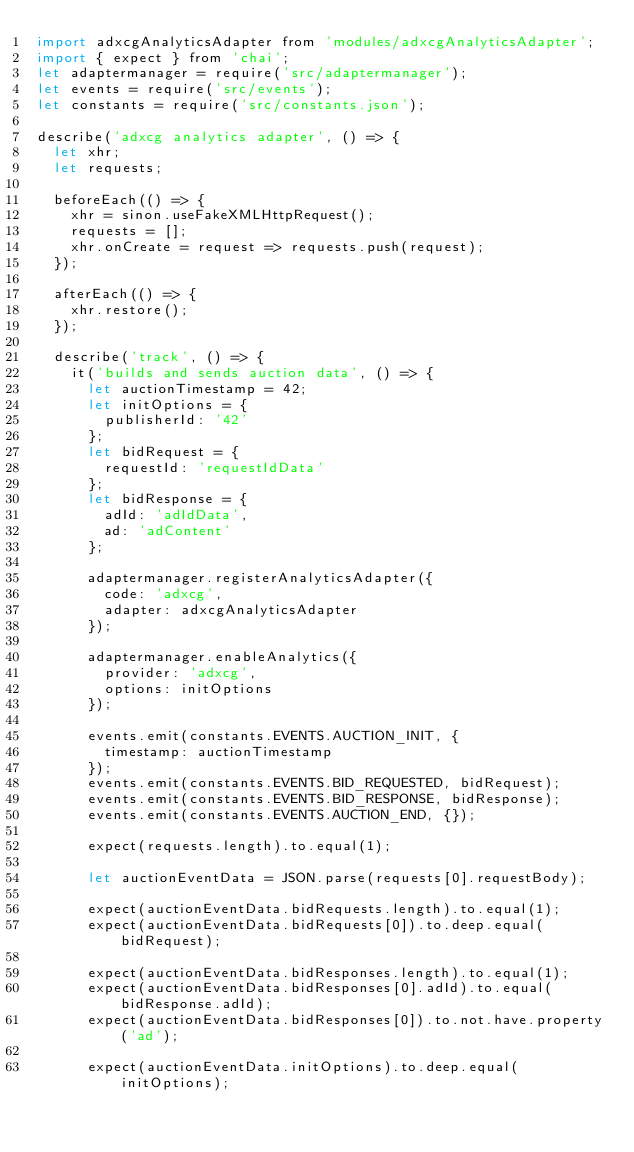Convert code to text. <code><loc_0><loc_0><loc_500><loc_500><_JavaScript_>import adxcgAnalyticsAdapter from 'modules/adxcgAnalyticsAdapter';
import { expect } from 'chai';
let adaptermanager = require('src/adaptermanager');
let events = require('src/events');
let constants = require('src/constants.json');

describe('adxcg analytics adapter', () => {
  let xhr;
  let requests;

  beforeEach(() => {
    xhr = sinon.useFakeXMLHttpRequest();
    requests = [];
    xhr.onCreate = request => requests.push(request);
  });

  afterEach(() => {
    xhr.restore();
  });

  describe('track', () => {
    it('builds and sends auction data', () => {
      let auctionTimestamp = 42;
      let initOptions = {
        publisherId: '42'
      };
      let bidRequest = {
        requestId: 'requestIdData'
      };
      let bidResponse = {
        adId: 'adIdData',
        ad: 'adContent'
      };

      adaptermanager.registerAnalyticsAdapter({
        code: 'adxcg',
        adapter: adxcgAnalyticsAdapter
      });

      adaptermanager.enableAnalytics({
        provider: 'adxcg',
        options: initOptions
      });

      events.emit(constants.EVENTS.AUCTION_INIT, {
        timestamp: auctionTimestamp
      });
      events.emit(constants.EVENTS.BID_REQUESTED, bidRequest);
      events.emit(constants.EVENTS.BID_RESPONSE, bidResponse);
      events.emit(constants.EVENTS.AUCTION_END, {});

      expect(requests.length).to.equal(1);

      let auctionEventData = JSON.parse(requests[0].requestBody);

      expect(auctionEventData.bidRequests.length).to.equal(1);
      expect(auctionEventData.bidRequests[0]).to.deep.equal(bidRequest);

      expect(auctionEventData.bidResponses.length).to.equal(1);
      expect(auctionEventData.bidResponses[0].adId).to.equal(bidResponse.adId);
      expect(auctionEventData.bidResponses[0]).to.not.have.property('ad');

      expect(auctionEventData.initOptions).to.deep.equal(initOptions);</code> 